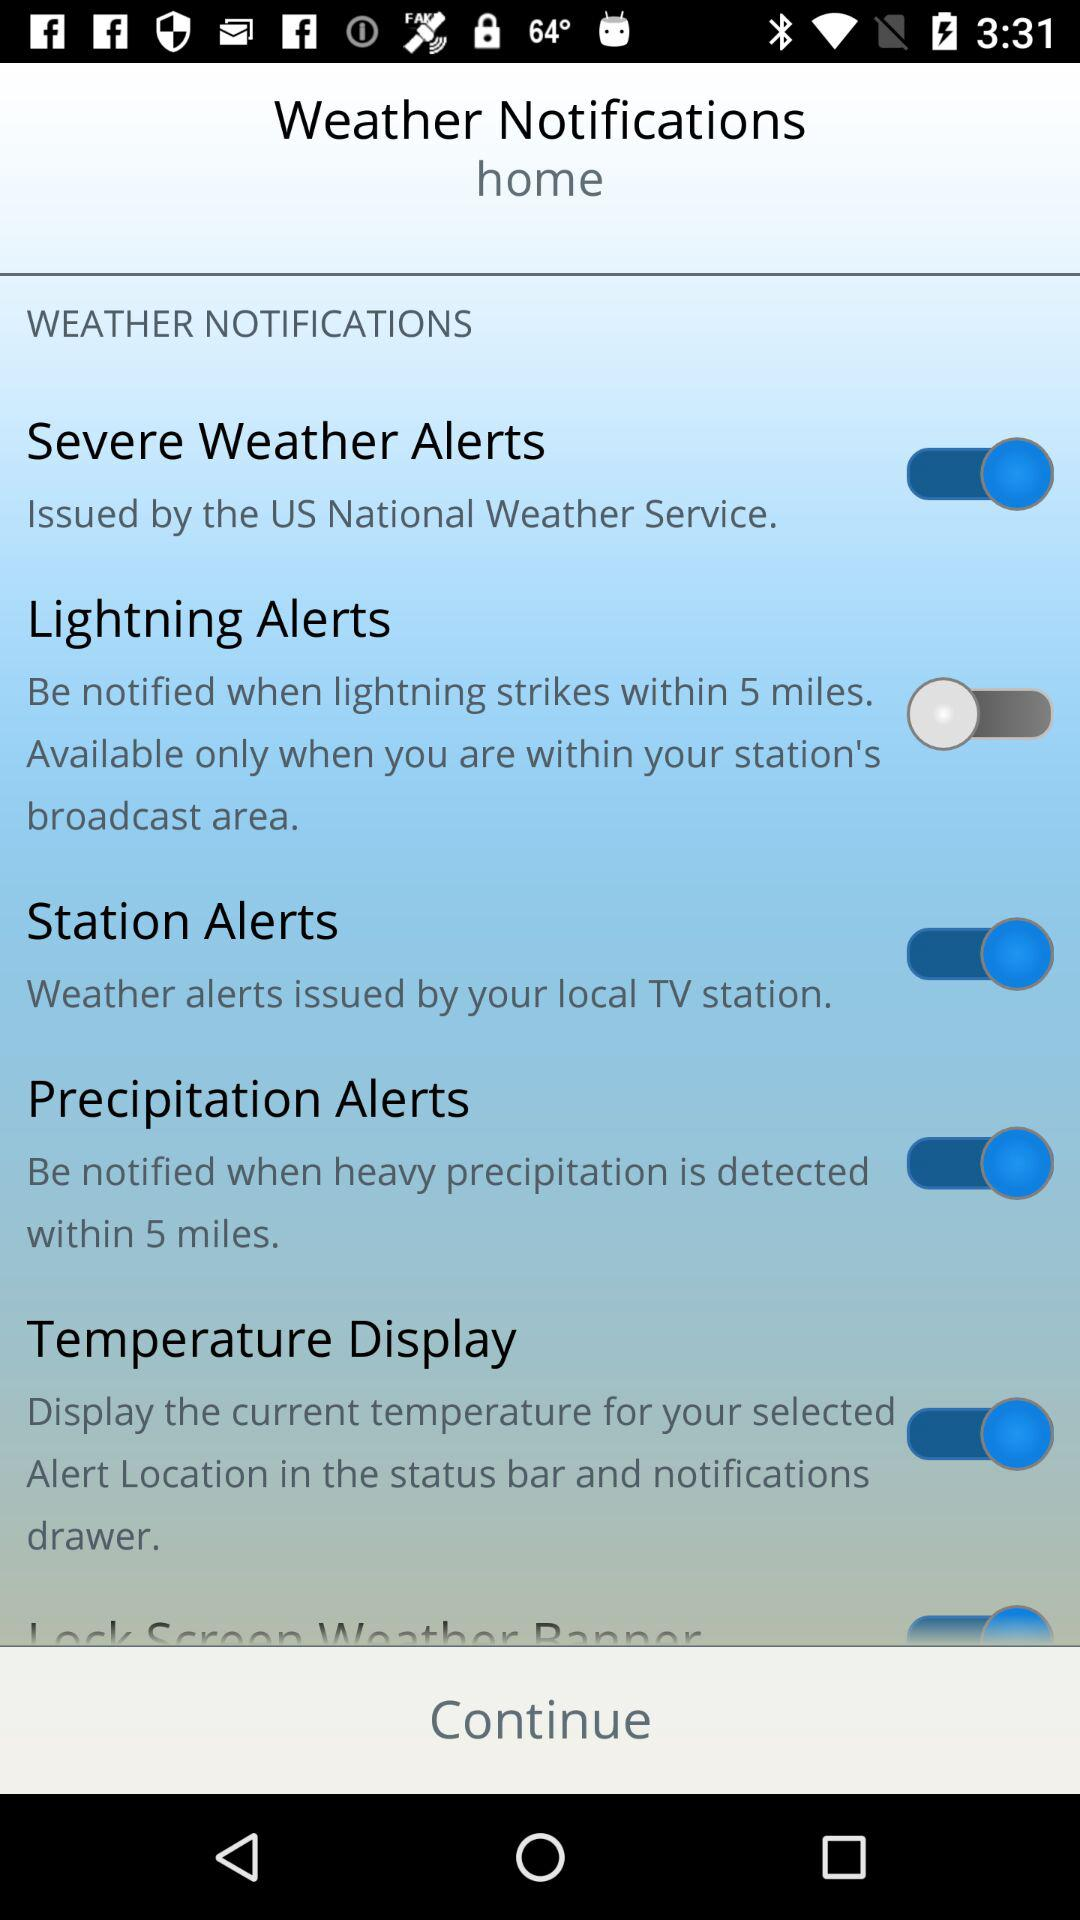How many alert types are available?
Answer the question using a single word or phrase. 5 